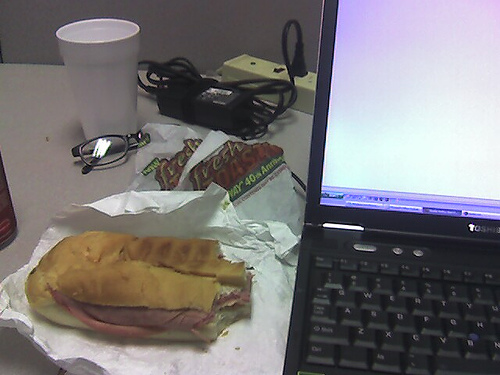What can be inferred about the time of day or the environment from the contents of the desk? The meal indicates it might be lunchtime. The presence of indoor lighting and the powered-on laptop suggest an indoor office environment. It's hard to determine the exact time of day without natural light or a view outside, but the scenario is typical for a midday meal break. 